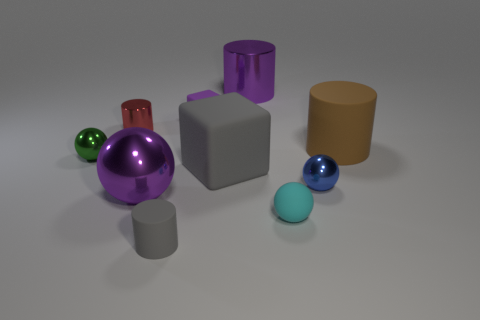What is the shape of the big purple shiny thing that is on the left side of the tiny purple cube that is behind the large brown rubber cylinder?
Give a very brief answer. Sphere. There is a cyan sphere; does it have the same size as the cube that is behind the brown rubber cylinder?
Offer a terse response. Yes. How big is the rubber cylinder to the right of the purple shiny object that is behind the tiny blue metallic ball that is behind the purple metallic ball?
Ensure brevity in your answer.  Large. How many things are either purple metallic things right of the small matte block or blocks?
Offer a terse response. 3. How many tiny spheres are on the right side of the cyan matte sphere that is on the left side of the large brown rubber cylinder?
Provide a short and direct response. 1. Are there more big purple cylinders that are in front of the cyan matte thing than small yellow rubber objects?
Ensure brevity in your answer.  No. There is a sphere that is both behind the big purple ball and on the left side of the gray cylinder; how big is it?
Provide a short and direct response. Small. There is a tiny matte object that is both to the left of the big purple metal cylinder and behind the small gray object; what is its shape?
Make the answer very short. Cube. Is there a big block to the right of the shiny sphere that is on the right side of the block in front of the tiny rubber block?
Provide a short and direct response. No. What number of things are green shiny spheres on the left side of the small red metallic cylinder or things that are on the right side of the small cyan rubber ball?
Offer a terse response. 3. 